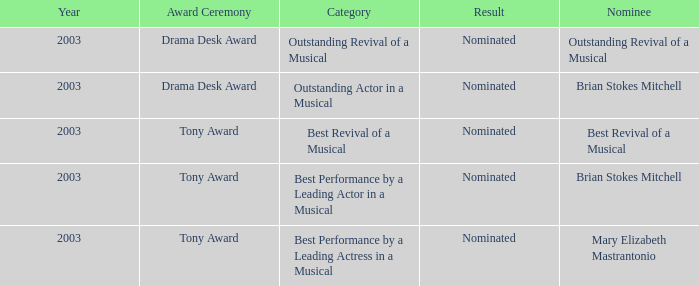What year was Mary Elizabeth Mastrantonio nominated? 2003.0. 